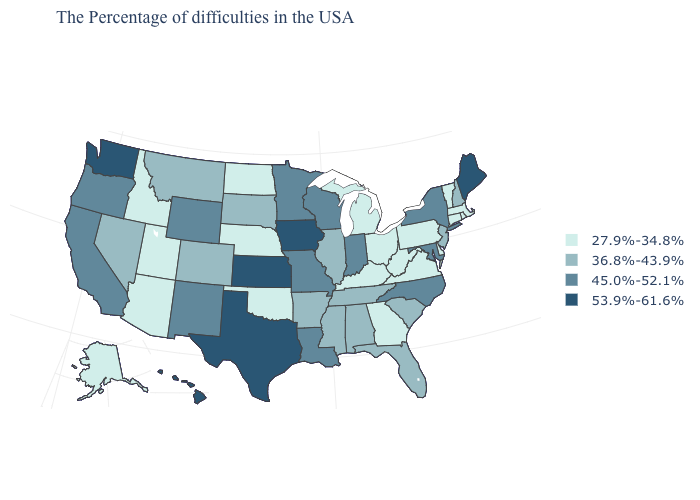Which states have the lowest value in the West?
Give a very brief answer. Utah, Arizona, Idaho, Alaska. What is the value of Pennsylvania?
Keep it brief. 27.9%-34.8%. Name the states that have a value in the range 53.9%-61.6%?
Quick response, please. Maine, Iowa, Kansas, Texas, Washington, Hawaii. What is the value of Arkansas?
Quick response, please. 36.8%-43.9%. Does the first symbol in the legend represent the smallest category?
Quick response, please. Yes. Name the states that have a value in the range 27.9%-34.8%?
Give a very brief answer. Massachusetts, Rhode Island, Vermont, Connecticut, Delaware, Pennsylvania, Virginia, West Virginia, Ohio, Georgia, Michigan, Kentucky, Nebraska, Oklahoma, North Dakota, Utah, Arizona, Idaho, Alaska. What is the value of New Hampshire?
Answer briefly. 36.8%-43.9%. Does Vermont have the lowest value in the USA?
Concise answer only. Yes. Does North Carolina have a higher value than Delaware?
Keep it brief. Yes. What is the highest value in states that border Florida?
Concise answer only. 36.8%-43.9%. Name the states that have a value in the range 36.8%-43.9%?
Concise answer only. New Hampshire, New Jersey, South Carolina, Florida, Alabama, Tennessee, Illinois, Mississippi, Arkansas, South Dakota, Colorado, Montana, Nevada. Does Wyoming have a higher value than Massachusetts?
Give a very brief answer. Yes. Does Oregon have a lower value than Massachusetts?
Be succinct. No. What is the lowest value in the West?
Keep it brief. 27.9%-34.8%. Does Iowa have the highest value in the USA?
Concise answer only. Yes. 